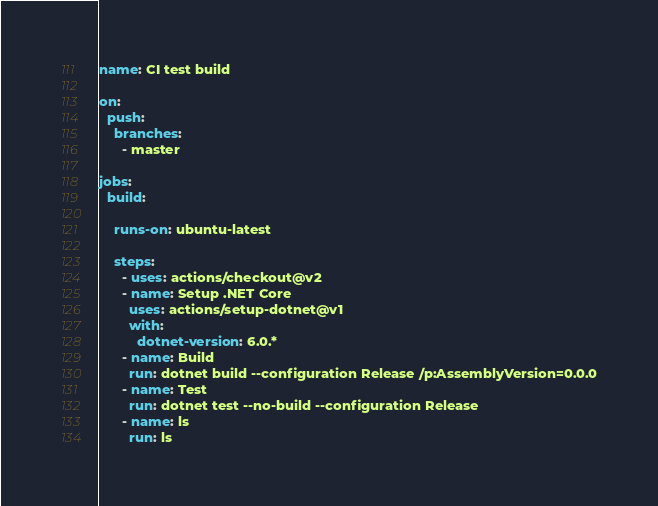<code> <loc_0><loc_0><loc_500><loc_500><_YAML_>name: CI test build

on:
  push:
    branches:
      - master

jobs:
  build:

    runs-on: ubuntu-latest

    steps:
      - uses: actions/checkout@v2
      - name: Setup .NET Core
        uses: actions/setup-dotnet@v1
        with:
          dotnet-version: 6.0.*
      - name: Build
        run: dotnet build --configuration Release /p:AssemblyVersion=0.0.0
      - name: Test
        run: dotnet test --no-build --configuration Release
      - name: ls
        run: ls

</code> 